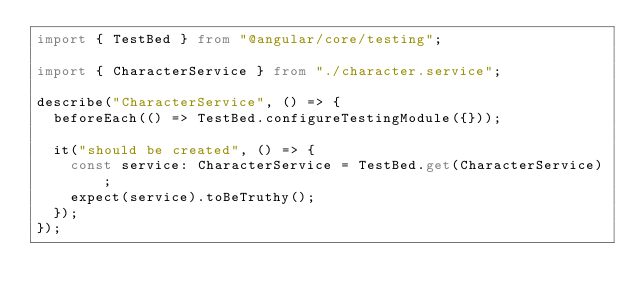Convert code to text. <code><loc_0><loc_0><loc_500><loc_500><_TypeScript_>import { TestBed } from "@angular/core/testing";

import { CharacterService } from "./character.service";

describe("CharacterService", () => {
  beforeEach(() => TestBed.configureTestingModule({}));

  it("should be created", () => {
    const service: CharacterService = TestBed.get(CharacterService);
    expect(service).toBeTruthy();
  });
});
</code> 